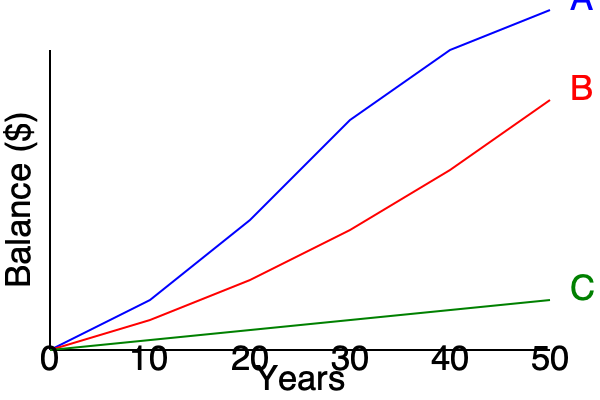As a SOAR member planning for retirement, which savings growth chart (A, B, or C) represents the most aggressive investment strategy with the highest potential returns over a 50-year period? To determine the most aggressive investment strategy with the highest potential returns, we need to analyze the three growth charts:

1. Chart A (Blue):
   - Shows the steepest upward curve
   - Ends at the highest point after 50 years
   - Indicates rapid growth, especially in later years

2. Chart B (Red):
   - Shows moderate upward growth
   - Ends at a middle point between A and C after 50 years
   - Indicates steady growth, but less aggressive than A

3. Chart C (Green):
   - Shows the shallowest upward curve
   - Ends at the lowest point after 50 years
   - Indicates slow, conservative growth

Comparing the three charts:
- Chart A has the highest end point and steepest curve, suggesting the highest returns.
- Chart B offers moderate growth and returns.
- Chart C provides the lowest growth and returns.

An aggressive investment strategy typically aims for higher returns by accepting higher risk. This is best represented by Chart A, which shows the potential for the highest returns over the 50-year period.
Answer: A 